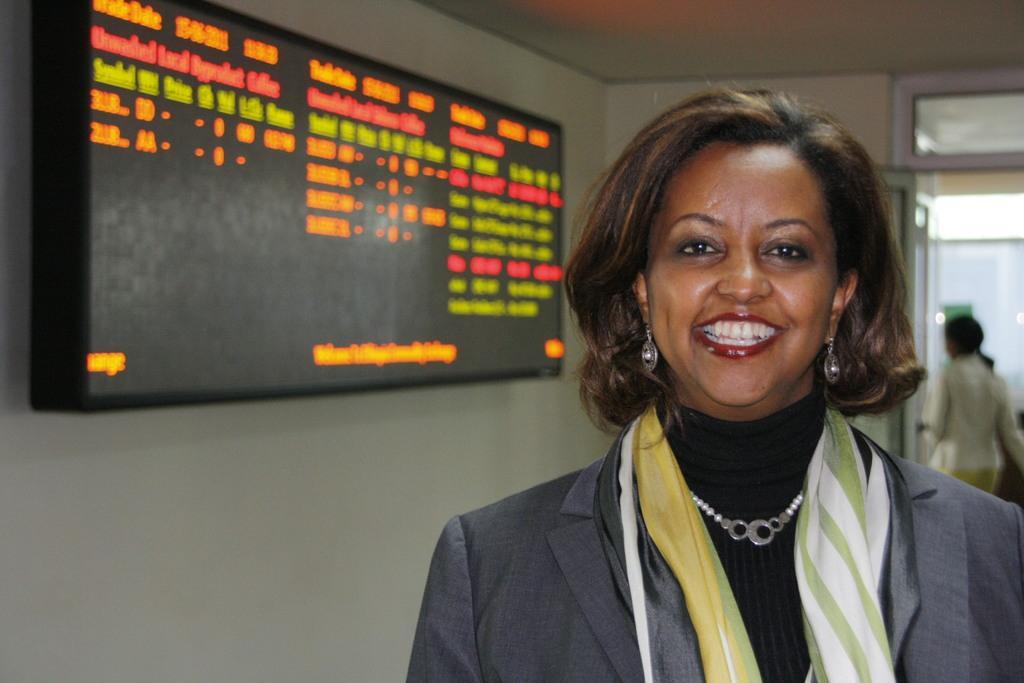Describe this image in one or two sentences. In this image I can see a woman wearing black color dress is standing and smiling. I can see a wall and a huge screen attached to the wall. In the background I can see the door and another person standing. 